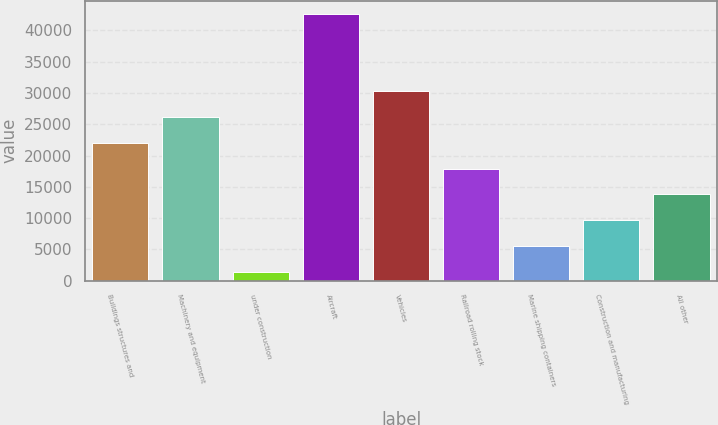Convert chart. <chart><loc_0><loc_0><loc_500><loc_500><bar_chart><fcel>Buildings structures and<fcel>Machinery and equipment<fcel>under construction<fcel>Aircraft<fcel>Vehicles<fcel>Railroad rolling stock<fcel>Marine shipping containers<fcel>Construction and manufacturing<fcel>All other<nl><fcel>22032.5<fcel>26152.8<fcel>1431<fcel>42634<fcel>30273.1<fcel>17912.2<fcel>5551.3<fcel>9671.6<fcel>13791.9<nl></chart> 